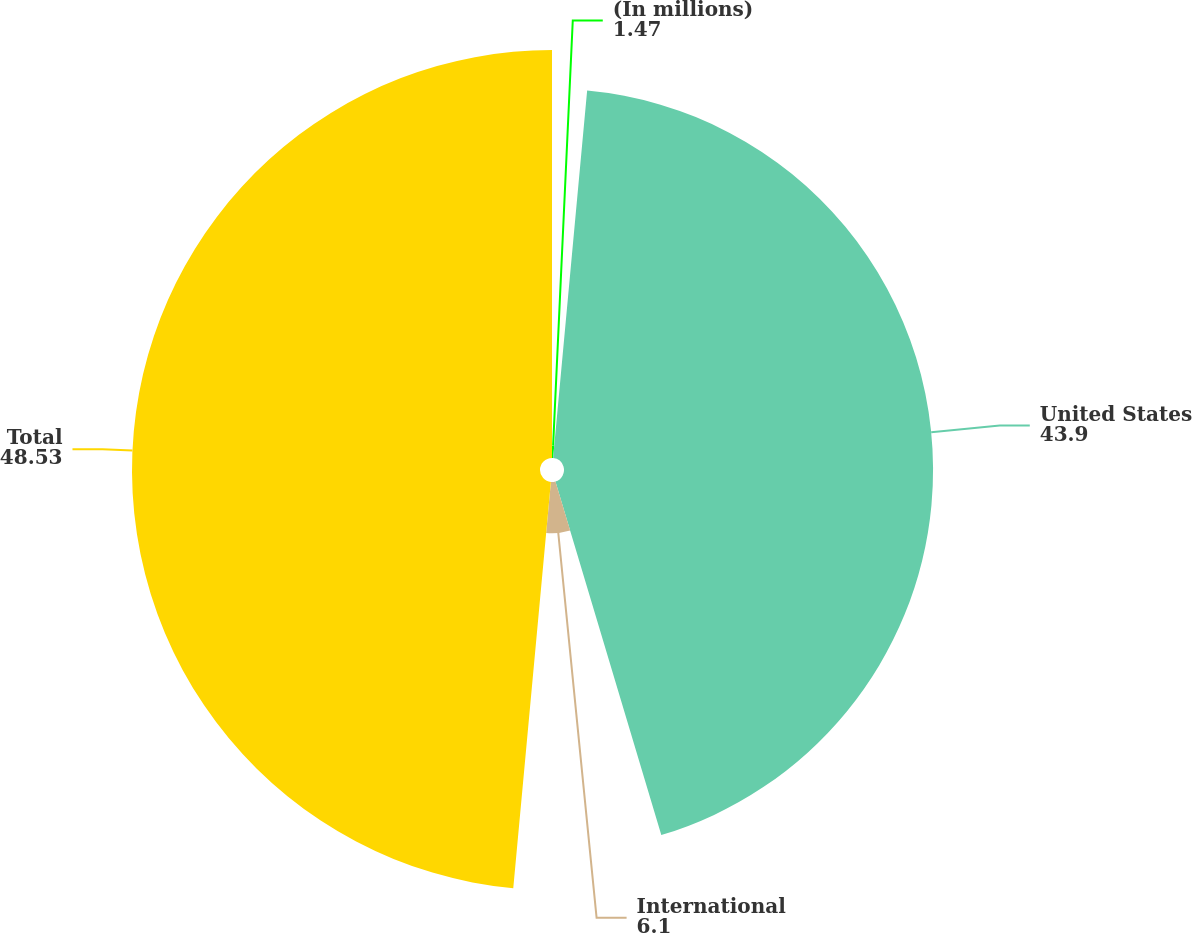<chart> <loc_0><loc_0><loc_500><loc_500><pie_chart><fcel>(In millions)<fcel>United States<fcel>International<fcel>Total<nl><fcel>1.47%<fcel>43.9%<fcel>6.1%<fcel>48.53%<nl></chart> 